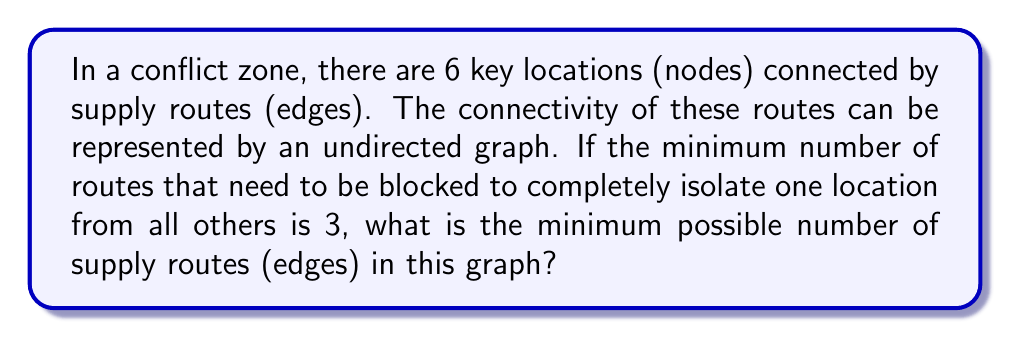Can you solve this math problem? To solve this problem, we need to use concepts from graph theory, specifically vertex connectivity.

1) First, let's define vertex connectivity. The vertex connectivity of a graph G, denoted by κ(G), is the minimum number of vertices whose removal disconnects the graph or reduces it to a single vertex.

2) In this case, we're told that the minimum number of routes that need to be blocked to isolate a location is 3. This means the vertex connectivity of our graph is 3, or κ(G) = 3.

3) There's a theorem in graph theory that relates the minimum degree of a graph (δ(G)) to its vertex connectivity:

   $$κ(G) ≤ δ(G)$$

4) This means that for our graph with κ(G) = 3, the minimum degree of any vertex must be at least 3.

5) Now, let's consider the minimum number of edges needed to satisfy this condition. If each of the 6 vertices has a minimum degree of 3, the total number of edges would be:

   $$\frac{6 * 3}{2} = 9$$

   We divide by 2 because each edge is counted twice (once for each of its endpoints).

6) However, this is a lower bound. We need to check if a graph with 9 edges can actually have κ(G) = 3.

7) The graph that achieves this is known as the wheel graph W_6, which consists of a cycle of 5 vertices, all connected to a central vertex.

8) The wheel graph W_6 has:
   - 6 vertices
   - 5 edges forming the outer cycle
   - 5 edges connecting the central vertex to each outer vertex
   - Total: 5 + 5 = 10 edges

9) This graph indeed has κ(G) = 3, as removing any 2 vertices will not disconnect the graph, but removing the central vertex and any two non-adjacent outer vertices will.

Therefore, the minimum possible number of supply routes is 10.
Answer: 10 edges 